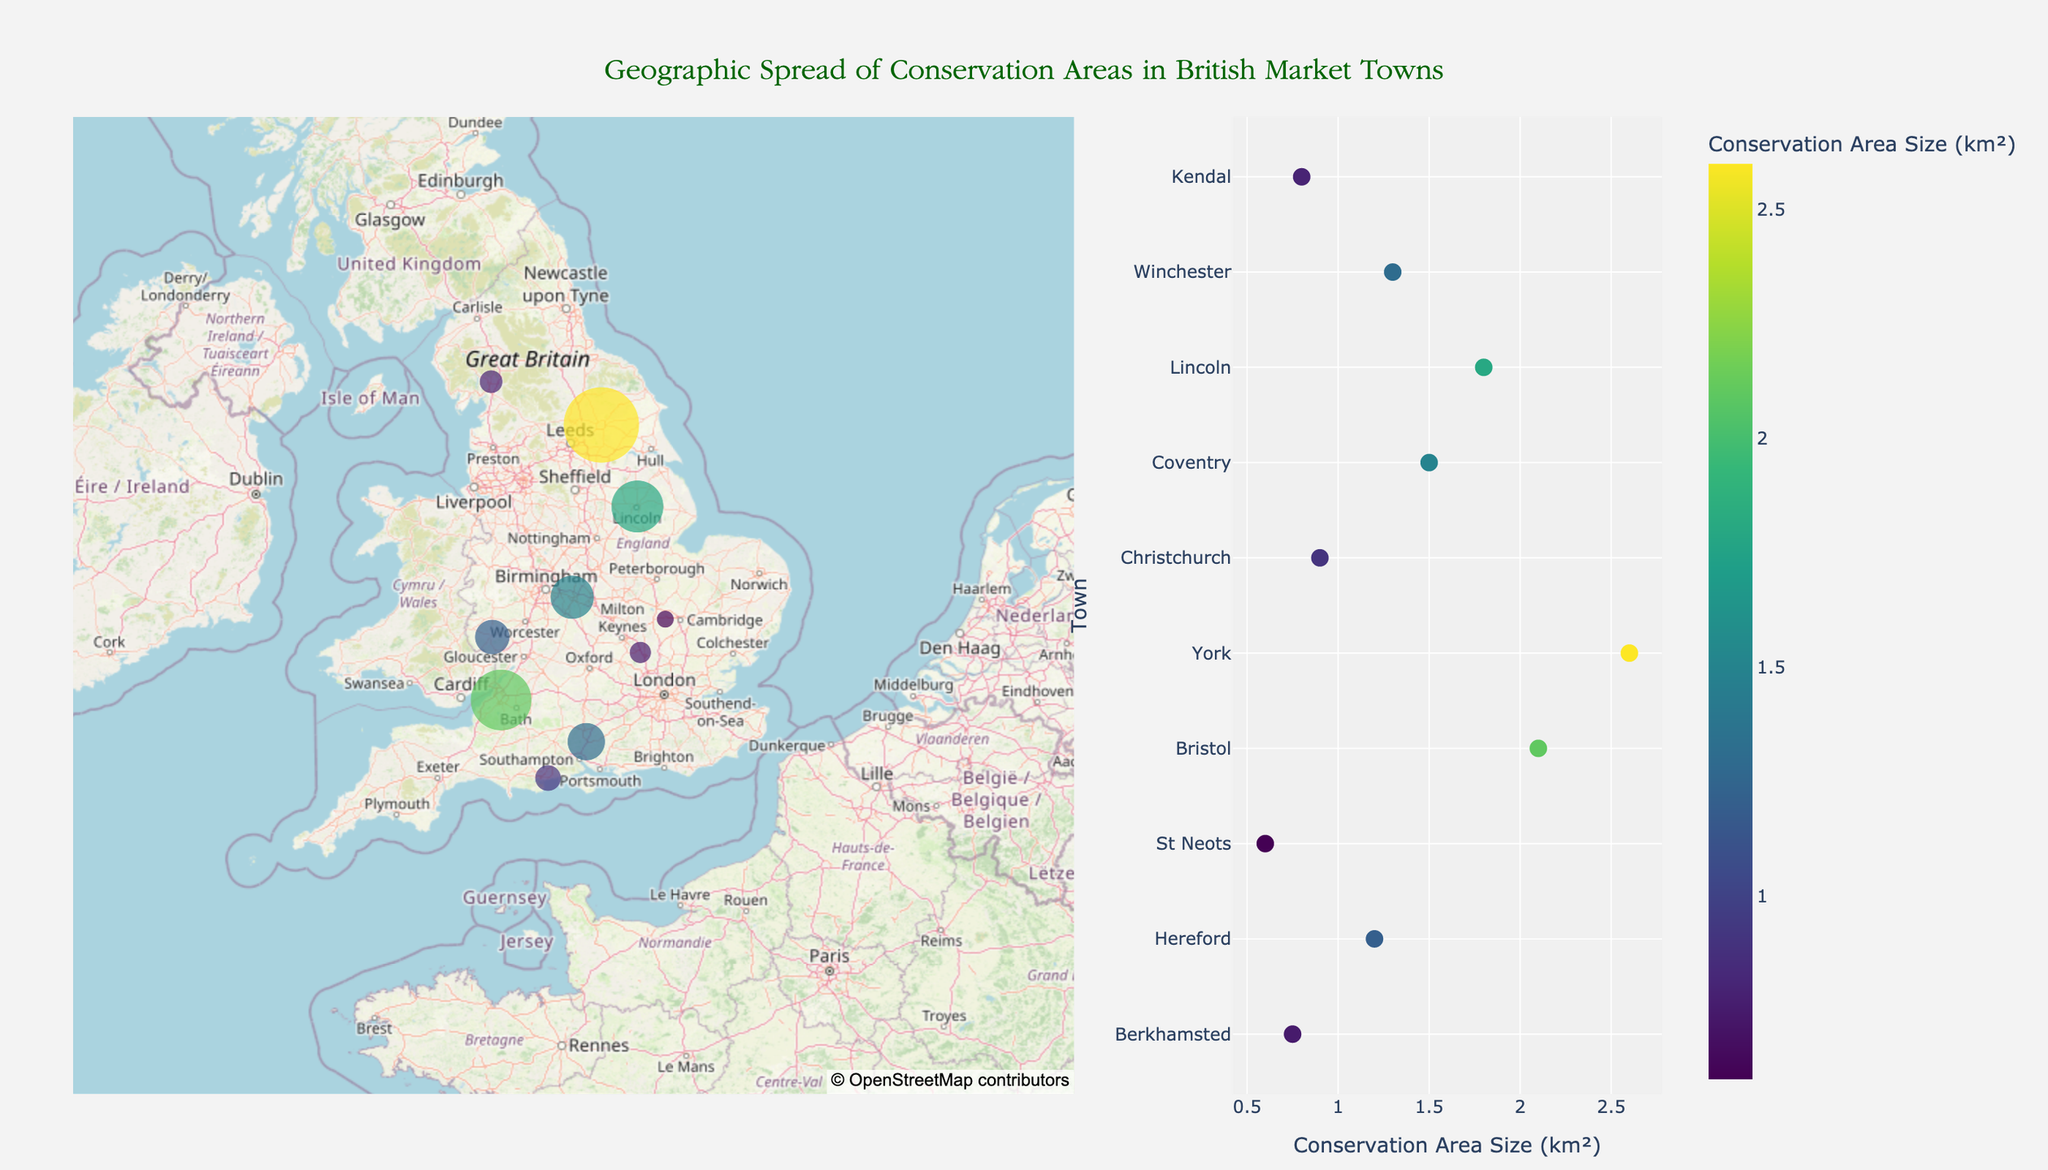What is the title of the figure? The title is usually located above the plot and is often in a larger or different font style from the other text in the figure. In this figure, the title reads "Geographic Spread of Conservation Areas in British Market Towns."
Answer: Geographic Spread of Conservation Areas in British Market Towns Which town has the largest conservation area? In the scatter plot on the right, the town with the highest value on the x-axis (Conservation Area Size in km²) is York. The map also supports this with York having the largest marker size and intensity.
Answer: York What notable building is associated with St Neots? Hover information in both the map and scatter plot provides details about notable buildings. For St Neots, the notable building is indicated as St Mary’s Church.
Answer: St Mary’s Church Compare the conservation area sizes of Hereford and Coventry. Which is larger? The scatter plot shows that Hereford has a conservation area size of 1.2 km², while Coventry has a size of 1.5 km². Therefore, Coventry has a larger conservation area.
Answer: Coventry Which town in North Yorkshire is included in the dataset? The hover information in the map shows towns and their counties. The town in North Yorkshire, as indicated, is York.
Answer: York What is the conservation area size for Winchester? Winchester’s conservation area size can be found in the scatter plot on the right. It shows that Winchester has a conservation area size of 1.3 km².
Answer: 1.3 km² Identify the town located at approximately latitude 54.34 and longitude -2.74. From the map, by looking at the marker near these coordinates, we can infer the town is Kendal.
Answer: Kendal What is the average conservation area size (in km²) of the listed towns? To find the average, sum all conservation area sizes (0.75 + 1.2 + 0.6 + 2.1 + 2.6 + 0.9 + 1.5 + 1.8 + 1.3 + 0.8) = 13.55, and divide by the number of towns (10). Therefore, the average is 13.55 / 10 = 1.355 km².
Answer: 1.355 km² 